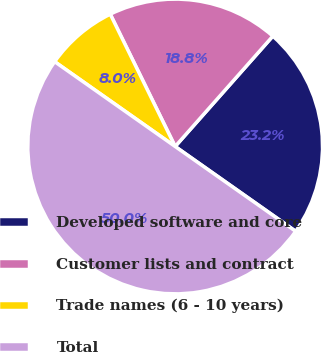<chart> <loc_0><loc_0><loc_500><loc_500><pie_chart><fcel>Developed software and core<fcel>Customer lists and contract<fcel>Trade names (6 - 10 years)<fcel>Total<nl><fcel>23.23%<fcel>18.79%<fcel>7.98%<fcel>50.0%<nl></chart> 